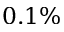<formula> <loc_0><loc_0><loc_500><loc_500>0 . 1 \%</formula> 